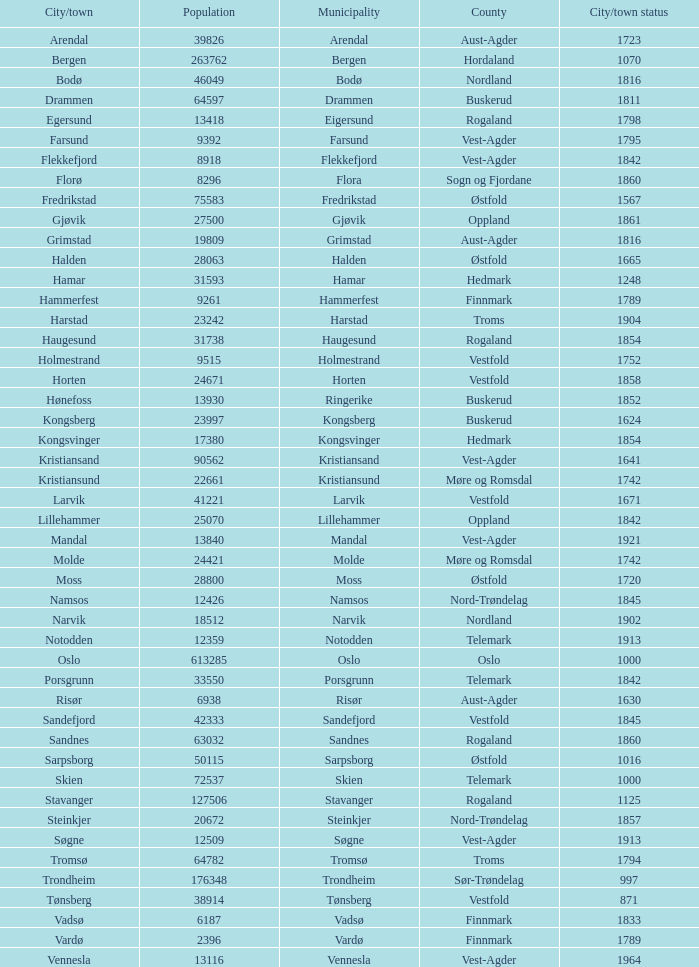Which municipalities located in the county of Finnmark have populations bigger than 6187.0? Hammerfest. Could you help me parse every detail presented in this table? {'header': ['City/town', 'Population', 'Municipality', 'County', 'City/town status'], 'rows': [['Arendal', '39826', 'Arendal', 'Aust-Agder', '1723'], ['Bergen', '263762', 'Bergen', 'Hordaland', '1070'], ['Bodø', '46049', 'Bodø', 'Nordland', '1816'], ['Drammen', '64597', 'Drammen', 'Buskerud', '1811'], ['Egersund', '13418', 'Eigersund', 'Rogaland', '1798'], ['Farsund', '9392', 'Farsund', 'Vest-Agder', '1795'], ['Flekkefjord', '8918', 'Flekkefjord', 'Vest-Agder', '1842'], ['Florø', '8296', 'Flora', 'Sogn og Fjordane', '1860'], ['Fredrikstad', '75583', 'Fredrikstad', 'Østfold', '1567'], ['Gjøvik', '27500', 'Gjøvik', 'Oppland', '1861'], ['Grimstad', '19809', 'Grimstad', 'Aust-Agder', '1816'], ['Halden', '28063', 'Halden', 'Østfold', '1665'], ['Hamar', '31593', 'Hamar', 'Hedmark', '1248'], ['Hammerfest', '9261', 'Hammerfest', 'Finnmark', '1789'], ['Harstad', '23242', 'Harstad', 'Troms', '1904'], ['Haugesund', '31738', 'Haugesund', 'Rogaland', '1854'], ['Holmestrand', '9515', 'Holmestrand', 'Vestfold', '1752'], ['Horten', '24671', 'Horten', 'Vestfold', '1858'], ['Hønefoss', '13930', 'Ringerike', 'Buskerud', '1852'], ['Kongsberg', '23997', 'Kongsberg', 'Buskerud', '1624'], ['Kongsvinger', '17380', 'Kongsvinger', 'Hedmark', '1854'], ['Kristiansand', '90562', 'Kristiansand', 'Vest-Agder', '1641'], ['Kristiansund', '22661', 'Kristiansund', 'Møre og Romsdal', '1742'], ['Larvik', '41221', 'Larvik', 'Vestfold', '1671'], ['Lillehammer', '25070', 'Lillehammer', 'Oppland', '1842'], ['Mandal', '13840', 'Mandal', 'Vest-Agder', '1921'], ['Molde', '24421', 'Molde', 'Møre og Romsdal', '1742'], ['Moss', '28800', 'Moss', 'Østfold', '1720'], ['Namsos', '12426', 'Namsos', 'Nord-Trøndelag', '1845'], ['Narvik', '18512', 'Narvik', 'Nordland', '1902'], ['Notodden', '12359', 'Notodden', 'Telemark', '1913'], ['Oslo', '613285', 'Oslo', 'Oslo', '1000'], ['Porsgrunn', '33550', 'Porsgrunn', 'Telemark', '1842'], ['Risør', '6938', 'Risør', 'Aust-Agder', '1630'], ['Sandefjord', '42333', 'Sandefjord', 'Vestfold', '1845'], ['Sandnes', '63032', 'Sandnes', 'Rogaland', '1860'], ['Sarpsborg', '50115', 'Sarpsborg', 'Østfold', '1016'], ['Skien', '72537', 'Skien', 'Telemark', '1000'], ['Stavanger', '127506', 'Stavanger', 'Rogaland', '1125'], ['Steinkjer', '20672', 'Steinkjer', 'Nord-Trøndelag', '1857'], ['Søgne', '12509', 'Søgne', 'Vest-Agder', '1913'], ['Tromsø', '64782', 'Tromsø', 'Troms', '1794'], ['Trondheim', '176348', 'Trondheim', 'Sør-Trøndelag', '997'], ['Tønsberg', '38914', 'Tønsberg', 'Vestfold', '871'], ['Vadsø', '6187', 'Vadsø', 'Finnmark', '1833'], ['Vardø', '2396', 'Vardø', 'Finnmark', '1789'], ['Vennesla', '13116', 'Vennesla', 'Vest-Agder', '1964']]} 